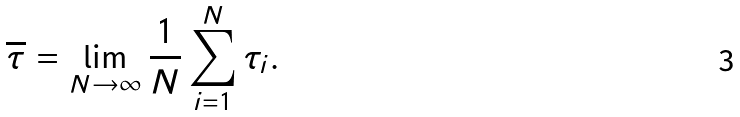<formula> <loc_0><loc_0><loc_500><loc_500>\overline { \tau } = \lim _ { N \rightarrow \infty } \frac { 1 } { N } \sum _ { i = 1 } ^ { N } \tau _ { i } .</formula> 